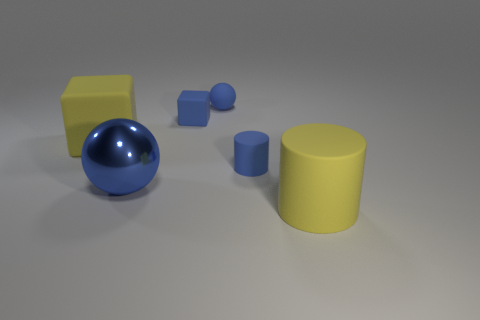Add 1 large yellow cubes. How many objects exist? 7 Subtract all blocks. How many objects are left? 4 Add 2 small blue things. How many small blue things exist? 5 Subtract 0 red blocks. How many objects are left? 6 Subtract all large matte cylinders. Subtract all tiny matte cylinders. How many objects are left? 4 Add 2 big matte blocks. How many big matte blocks are left? 3 